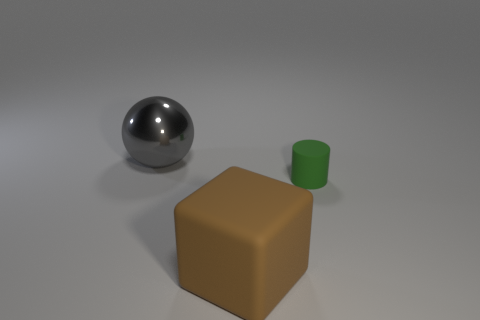How would you describe the arrangement of these objects? The arrangement of the objects is simple and spaced out. The large brown block is positioned centrally, with the small green cylindrical object to the right and the reflective sphere to the left, creating an asymmetrical yet balanced composition. Does the arrangement imply anything about the relative importance of the objects? Not necessarily. In this neutral setting, the arrangement seems arbitrary rather than designed to imply a hierarchy. The central positioning of the brown block might draw the eye first, but each object is distinct enough in shape and color to stand out on its own. 